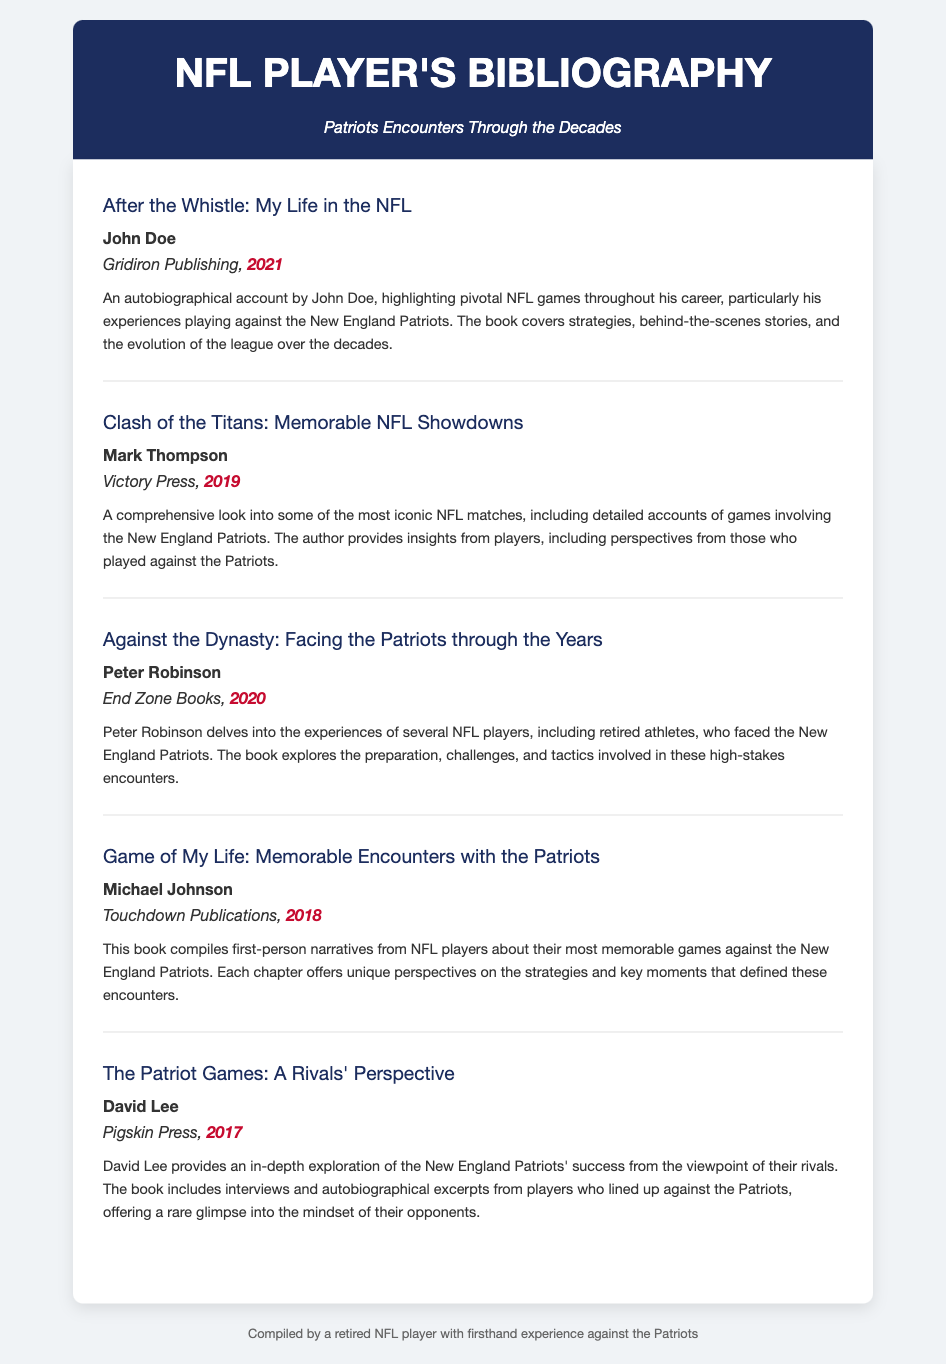What is the title of John Doe's book? The title of the book by John Doe is "After the Whistle: My Life in the NFL."
Answer: After the Whistle: My Life in the NFL Who published "Clash of the Titans: Memorable NFL Showdowns"? The publisher of "Clash of the Titans: Memorable NFL Showdowns" is Victory Press.
Answer: Victory Press What year was "Against the Dynasty: Facing the Patriots through the Years" published? The publication year of "Against the Dynasty: Facing the Patriots through the Years" is 2020.
Answer: 2020 How many entries list the author Michael Johnson? There is one entry that lists Michael Johnson as the author.
Answer: 1 What is a common theme among the books in this bibliography? The common theme is the experiences of players against the New England Patriots.
Answer: Experiences against the Patriots Who provides an in-depth exploration of the Patriots' success? David Lee provides this exploration in his book.
Answer: David Lee Which book focuses specifically on first-person narratives? The book that focuses on first-person narratives is "Game of My Life: Memorable Encounters with the Patriots."
Answer: Game of My Life: Memorable Encounters with the Patriots How many entries are in the bibliography? There are five entries in total in the bibliography.
Answer: 5 What type of document is this bibliography? This document is a bibliography specifically about autobiographical accounts of key NFL matches.
Answer: Bibliography 